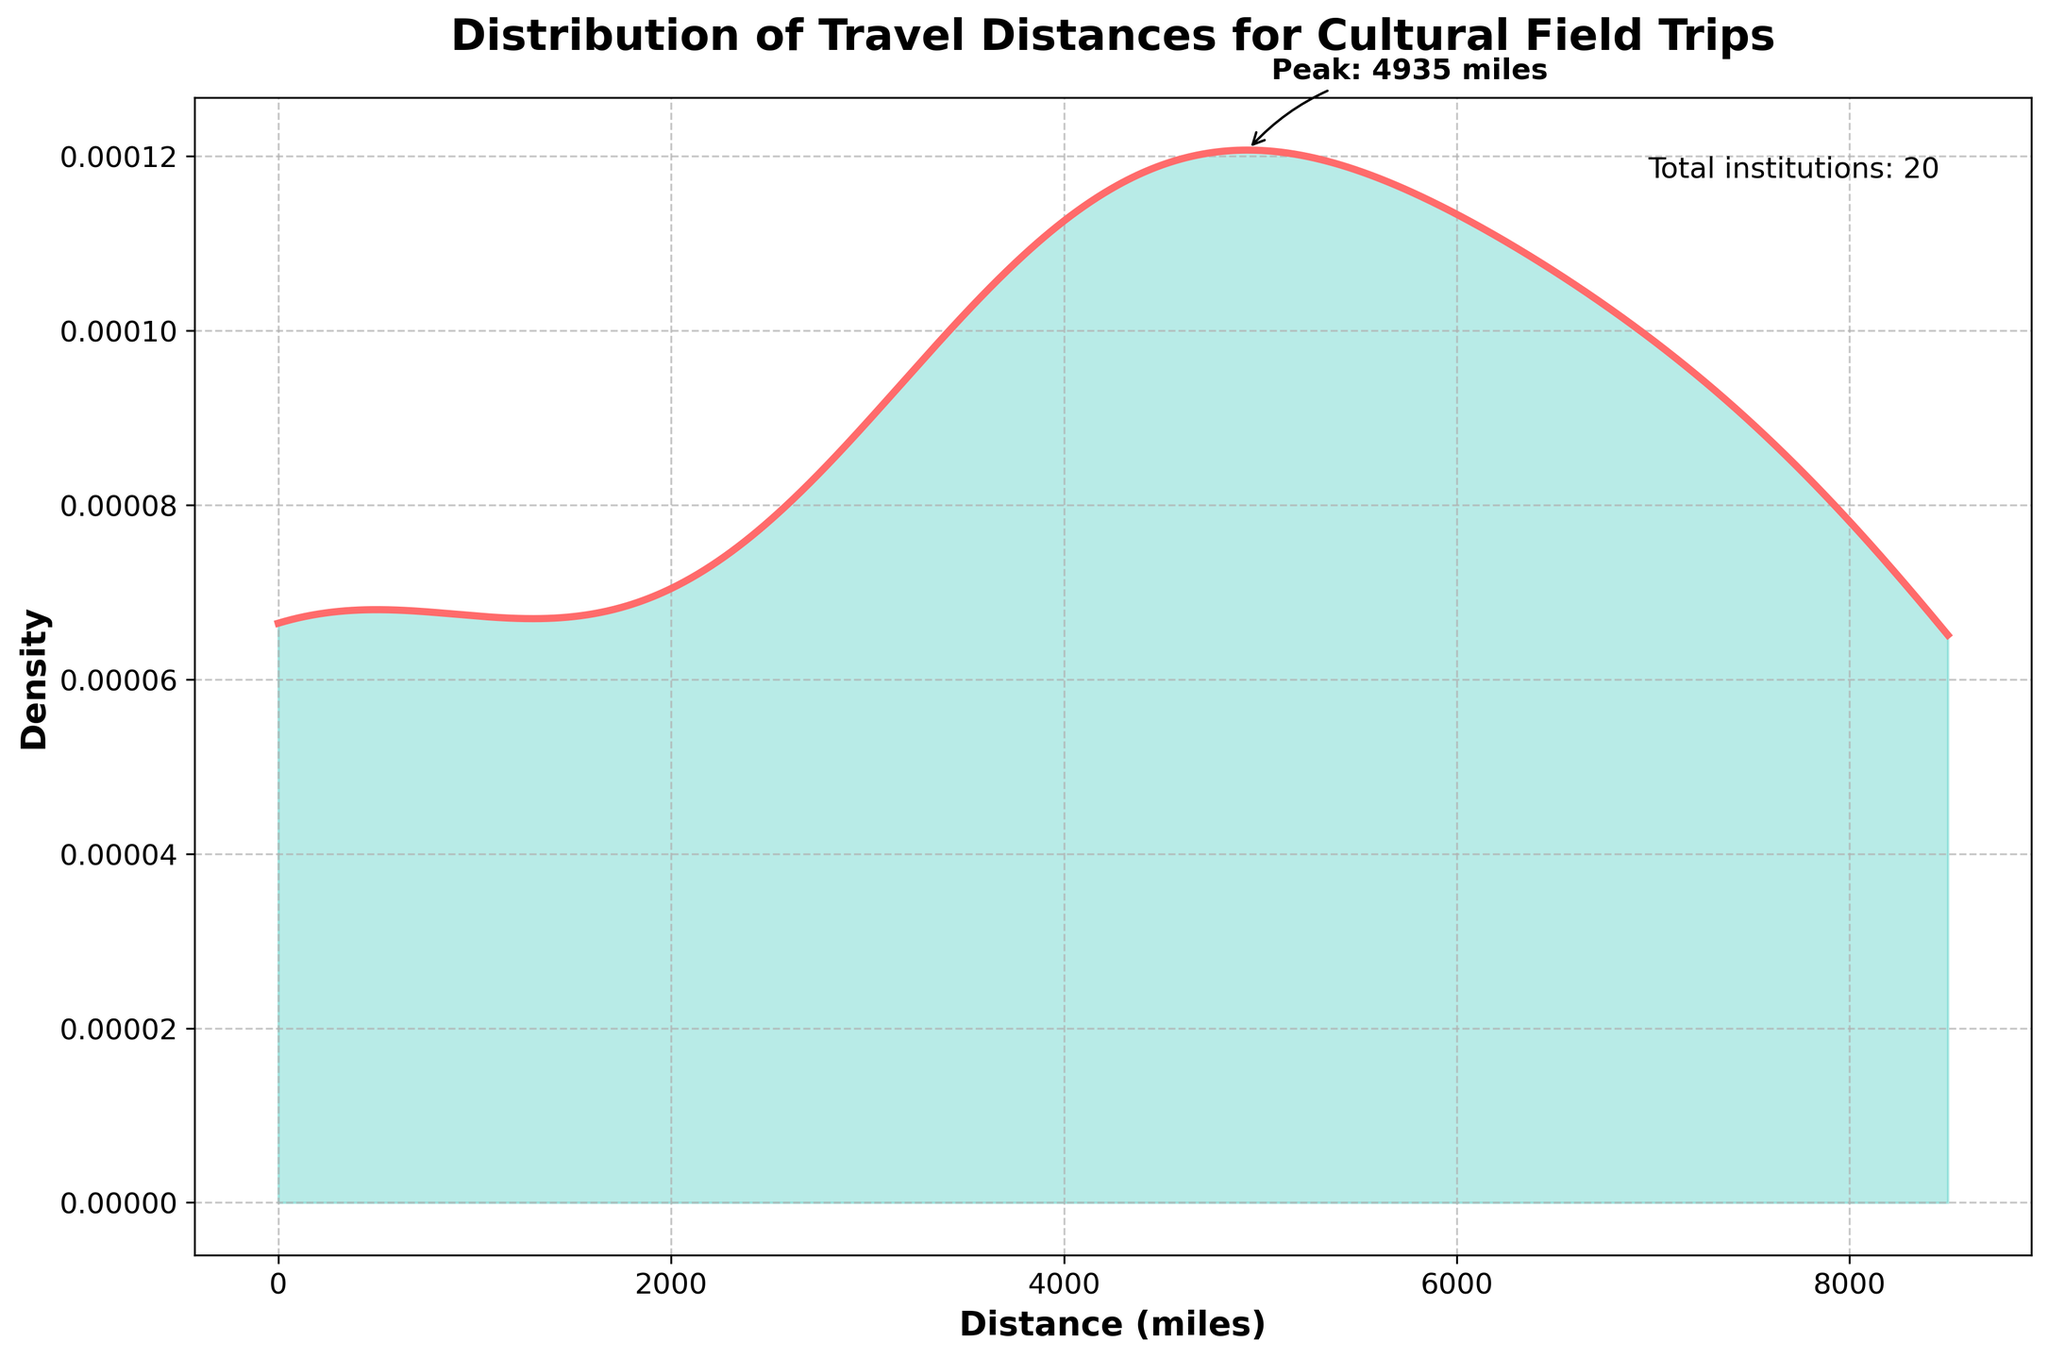What is the title of the plot? The title is typically located at the top of the plot, and in this case, it indicates the primary focus of the chart. You simply read it from the top part of the figure.
Answer: Distribution of Travel Distances for Cultural Field Trips What is the distance where the peak density occurs? The peak density is where the curve reaches its highest point. The plot has an annotation arrows pointing to the highest density point, indicating the peak distance.
Answer: 15 miles How many institutions are included in the dataset? The total number of institutions is mentioned in a text box within the plot, typically located somewhere around the figure's vicinity to provide additional context.
Answer: 20 What is the x-axis labeled as? The x-axis label is found at the bottom part of the plot and it tells what the horizontal axis represents.
Answer: Distance (miles) Is there a grid on the plot? The grid can be observed as a set of intersecting lines in the background of the figure, which helps in aligning and reading the data points more clearly.
Answer: Yes What is the range of travel distances shown on the x-axis? To determine the range, look at the minimum and maximum values on the x-axis. It spans from the lowest to the highest value marked on this axis.
Answer: 0 to 8500 miles What color is used to fill the area under the density plot? The fill color under the density curve is visible by looking closely at the area under the plotted line.
Answer: Turquoise What is the distance where the density starts to fill significantly under the curve after the peak? After the peak at 15 miles, you look at where the next notable density increase occurs, focusing on where the curve stays closer to the x-axis before rising again.
Answer: Around 3600 miles Describe the overall shape of the density distribution. Observing the density curve's overall shape involves noting its peaks and troughs; in this case, a primary peak followed by a flatter distribution and further peaks at larger distances.
Answer: One sharp peak at 15 miles, then flatter with smaller peaks beyond 3600 miles What is the general trend of the density as the distance increases? To analyze the trend, examine how the density values change as you move from left to right along the x-axis, noting the rises and falls.
Answer: Decreases significantly after the peak at 15 miles, with smaller peaks around higher distances 